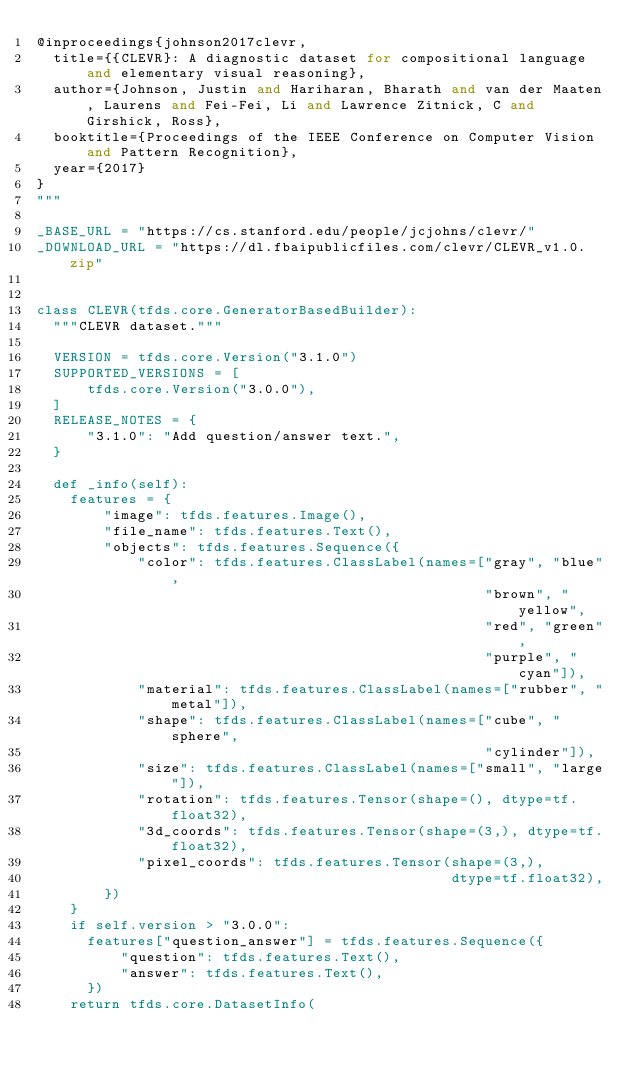<code> <loc_0><loc_0><loc_500><loc_500><_Python_>@inproceedings{johnson2017clevr,
  title={{CLEVR}: A diagnostic dataset for compositional language and elementary visual reasoning},
  author={Johnson, Justin and Hariharan, Bharath and van der Maaten, Laurens and Fei-Fei, Li and Lawrence Zitnick, C and Girshick, Ross},
  booktitle={Proceedings of the IEEE Conference on Computer Vision and Pattern Recognition},
  year={2017}
}
"""

_BASE_URL = "https://cs.stanford.edu/people/jcjohns/clevr/"
_DOWNLOAD_URL = "https://dl.fbaipublicfiles.com/clevr/CLEVR_v1.0.zip"


class CLEVR(tfds.core.GeneratorBasedBuilder):
  """CLEVR dataset."""

  VERSION = tfds.core.Version("3.1.0")
  SUPPORTED_VERSIONS = [
      tfds.core.Version("3.0.0"),
  ]
  RELEASE_NOTES = {
      "3.1.0": "Add question/answer text.",
  }

  def _info(self):
    features = {
        "image": tfds.features.Image(),
        "file_name": tfds.features.Text(),
        "objects": tfds.features.Sequence({
            "color": tfds.features.ClassLabel(names=["gray", "blue",
                                                     "brown", "yellow",
                                                     "red", "green",
                                                     "purple", "cyan"]),
            "material": tfds.features.ClassLabel(names=["rubber", "metal"]),
            "shape": tfds.features.ClassLabel(names=["cube", "sphere",
                                                     "cylinder"]),
            "size": tfds.features.ClassLabel(names=["small", "large"]),
            "rotation": tfds.features.Tensor(shape=(), dtype=tf.float32),
            "3d_coords": tfds.features.Tensor(shape=(3,), dtype=tf.float32),
            "pixel_coords": tfds.features.Tensor(shape=(3,),
                                                 dtype=tf.float32),
        })
    }
    if self.version > "3.0.0":
      features["question_answer"] = tfds.features.Sequence({
          "question": tfds.features.Text(),
          "answer": tfds.features.Text(),
      })
    return tfds.core.DatasetInfo(</code> 